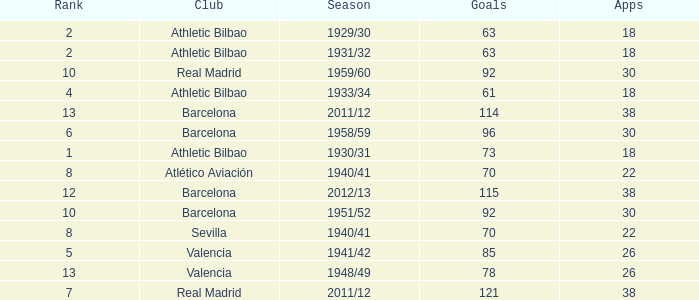What season was Barcelona ranked higher than 12, had more than 96 goals and had more than 26 apps? 2011/12. 